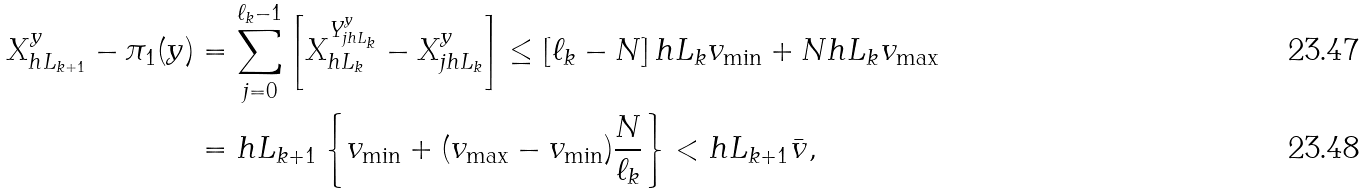Convert formula to latex. <formula><loc_0><loc_0><loc_500><loc_500>X ^ { y } _ { h L _ { k + 1 } } - \pi _ { 1 } ( y ) & = \sum _ { j = 0 } ^ { \ell _ { k } - 1 } \left [ X ^ { Y ^ { y } _ { j h L _ { k } } } _ { h L _ { k } } - X ^ { y } _ { j h L _ { k } } \right ] \leq \left [ \ell _ { k } - N \right ] h L _ { k } v _ { \min } + N h L _ { k } v _ { \max } \\ & = h L _ { k + 1 } \left \{ v _ { \min } + ( v _ { \max } - v _ { \min } ) \frac { N } { \ell _ { k } } \right \} < h L _ { k + 1 } \bar { v } ,</formula> 